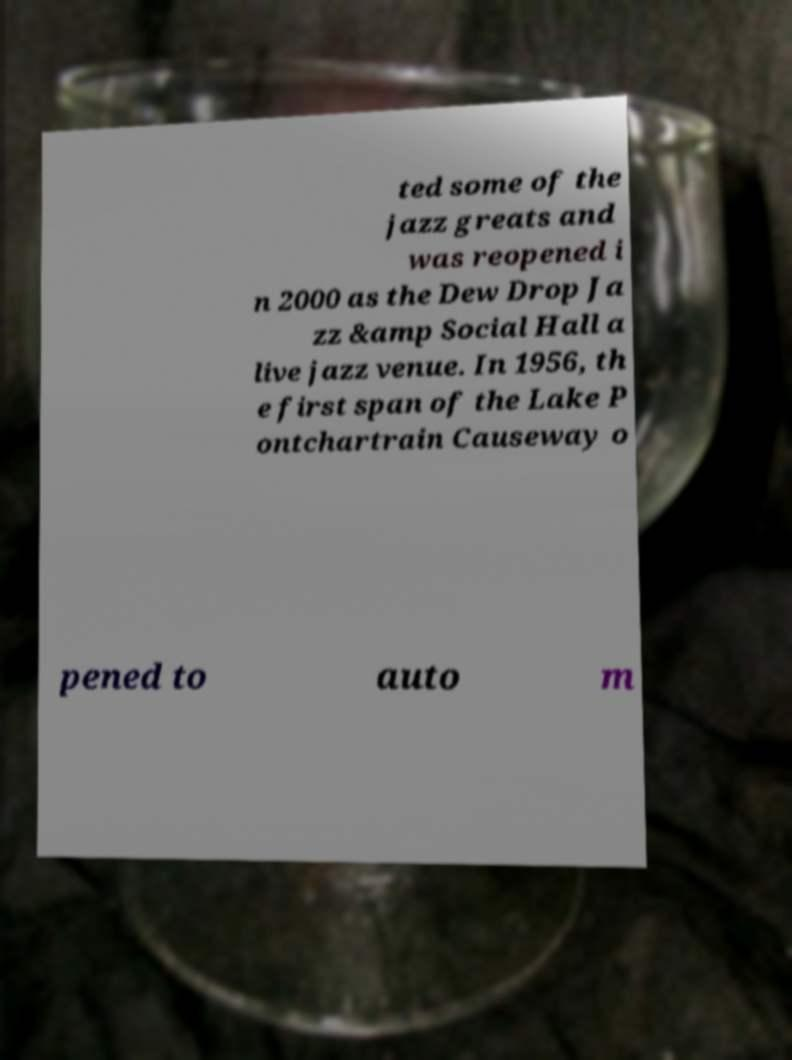For documentation purposes, I need the text within this image transcribed. Could you provide that? ted some of the jazz greats and was reopened i n 2000 as the Dew Drop Ja zz &amp Social Hall a live jazz venue. In 1956, th e first span of the Lake P ontchartrain Causeway o pened to auto m 